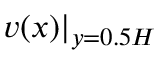Convert formula to latex. <formula><loc_0><loc_0><loc_500><loc_500>v ( x ) | _ { y = 0 . 5 H }</formula> 